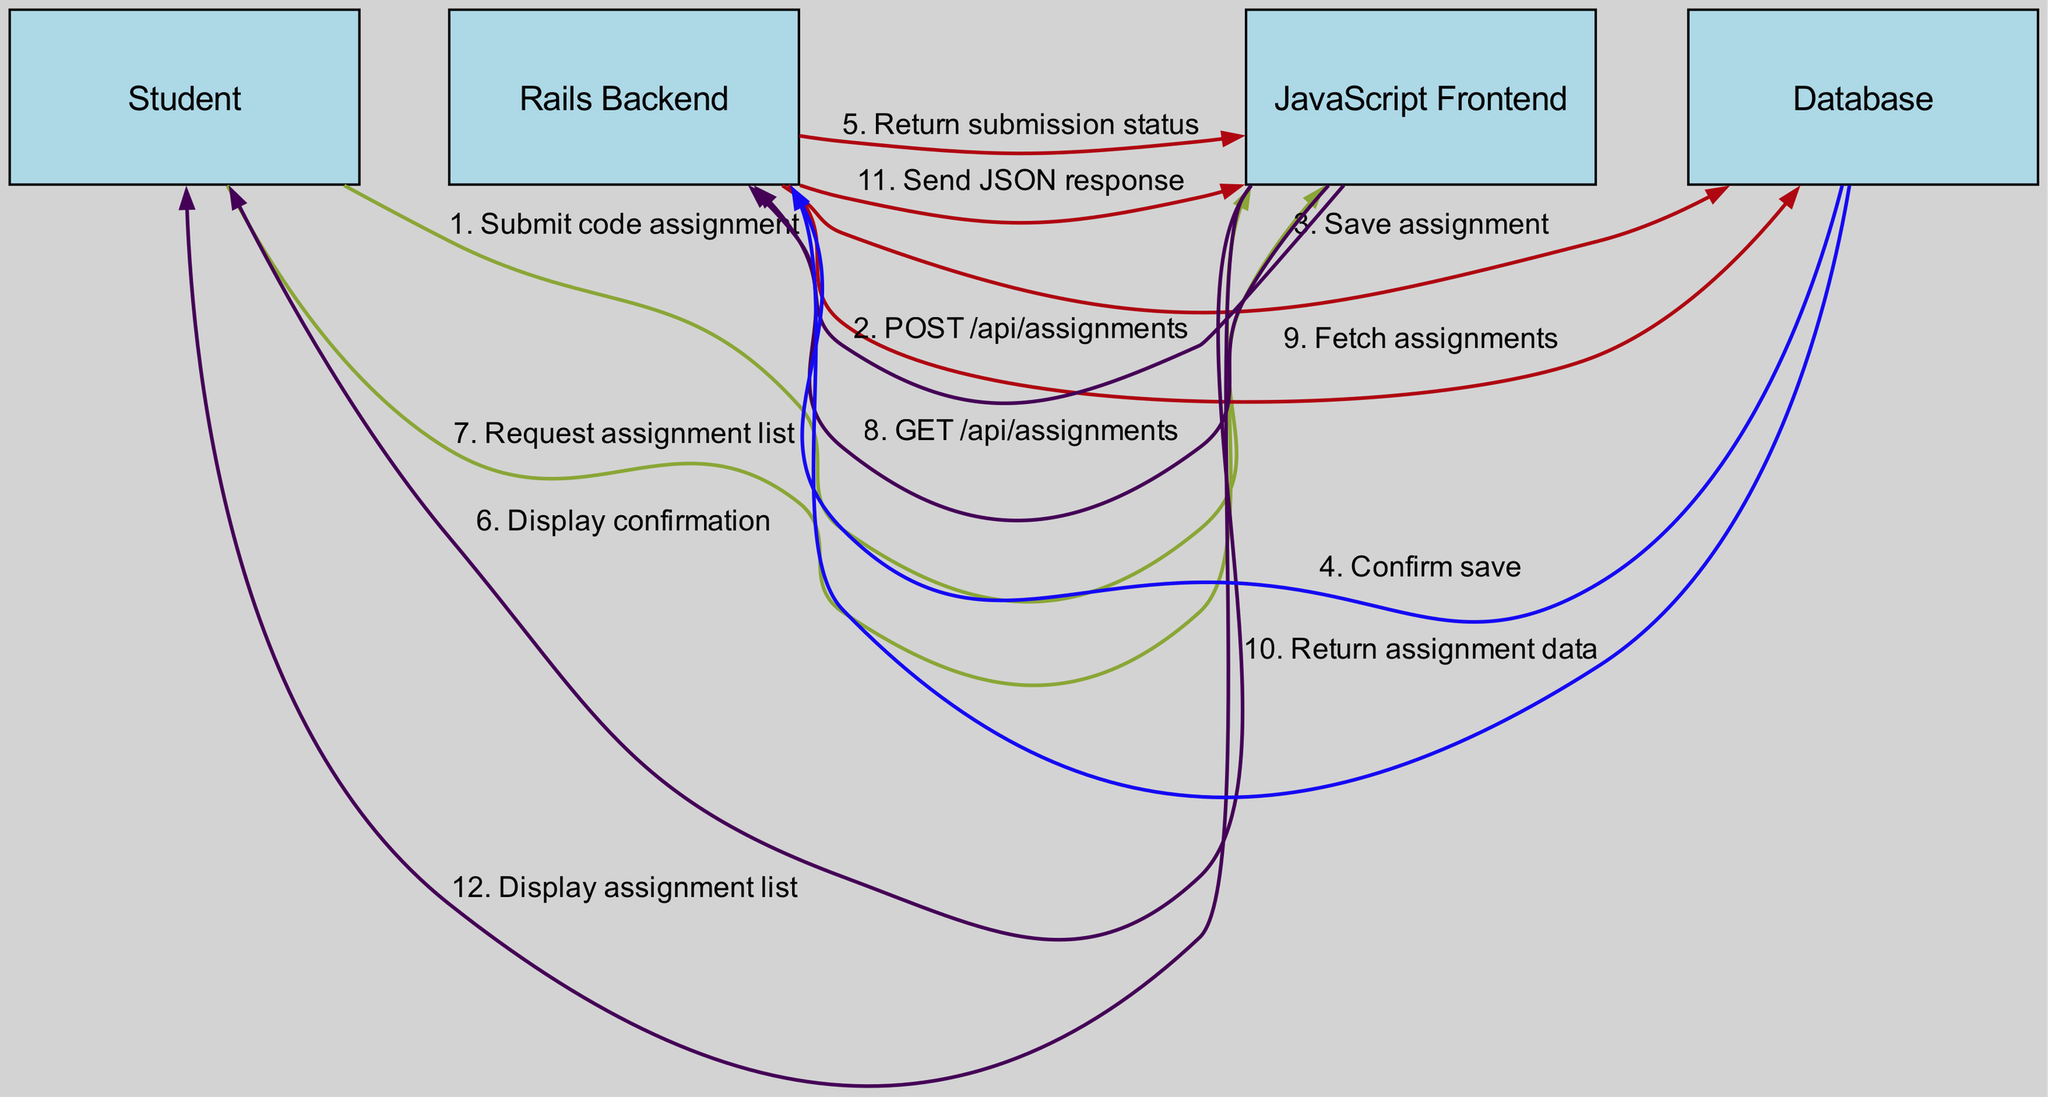What action does the Student take first? The first action in the diagram that includes the Student actor is "Submit code assignment." This action initiates the process in the sequence diagram.
Answer: Submit code assignment How many actors are involved in the sequence diagram? The diagram lists four distinct actors: Student, Rails Backend, JavaScript Frontend, and Database. This total accounts for all the nodes presented in the diagram.
Answer: Four What is the last action taken in the sequence between the JavaScript Frontend and the Student? The last action communicated in the interaction flow is "Display assignment list." This action concludes the sequence of interactions after fetching and returning assignment data.
Answer: Display assignment list Which component sends the confirmation of saving the assignment? The Database sends the "Confirm save" back to the Rails Backend. This indicates that the assignment has been successfully saved in the system.
Answer: Database What type of request does the JavaScript Frontend make in the second-to-last interaction? The JavaScript Frontend performs a "GET" request to the Rails Backend in the second-to-last interaction, specifically to "/api/assignments" to retrieve the list of assignments.
Answer: GET /api/assignments What is the interaction count that happens between the Database and the Rails Backend? There are two interactions between the Database and the Rails Backend: one for saving the assignment and one for fetching assignments. This count includes both the confirmation and the data return actions.
Answer: Two In the submission process, how many interactions take place before the confirmation is displayed to the Student? There are five interactions that occur before the confirmation is displayed. These consist of submitting the assignment, posting to the backend, saving to the database, confirming the save, and returning the status.
Answer: Five Who is responsible for displaying the assignment list to the Student? The JavaScript Frontend is responsible for displaying the assignment list to the Student after receiving the JSON response from the Rails Backend.
Answer: JavaScript Frontend 